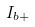<formula> <loc_0><loc_0><loc_500><loc_500>I _ { b + }</formula> 